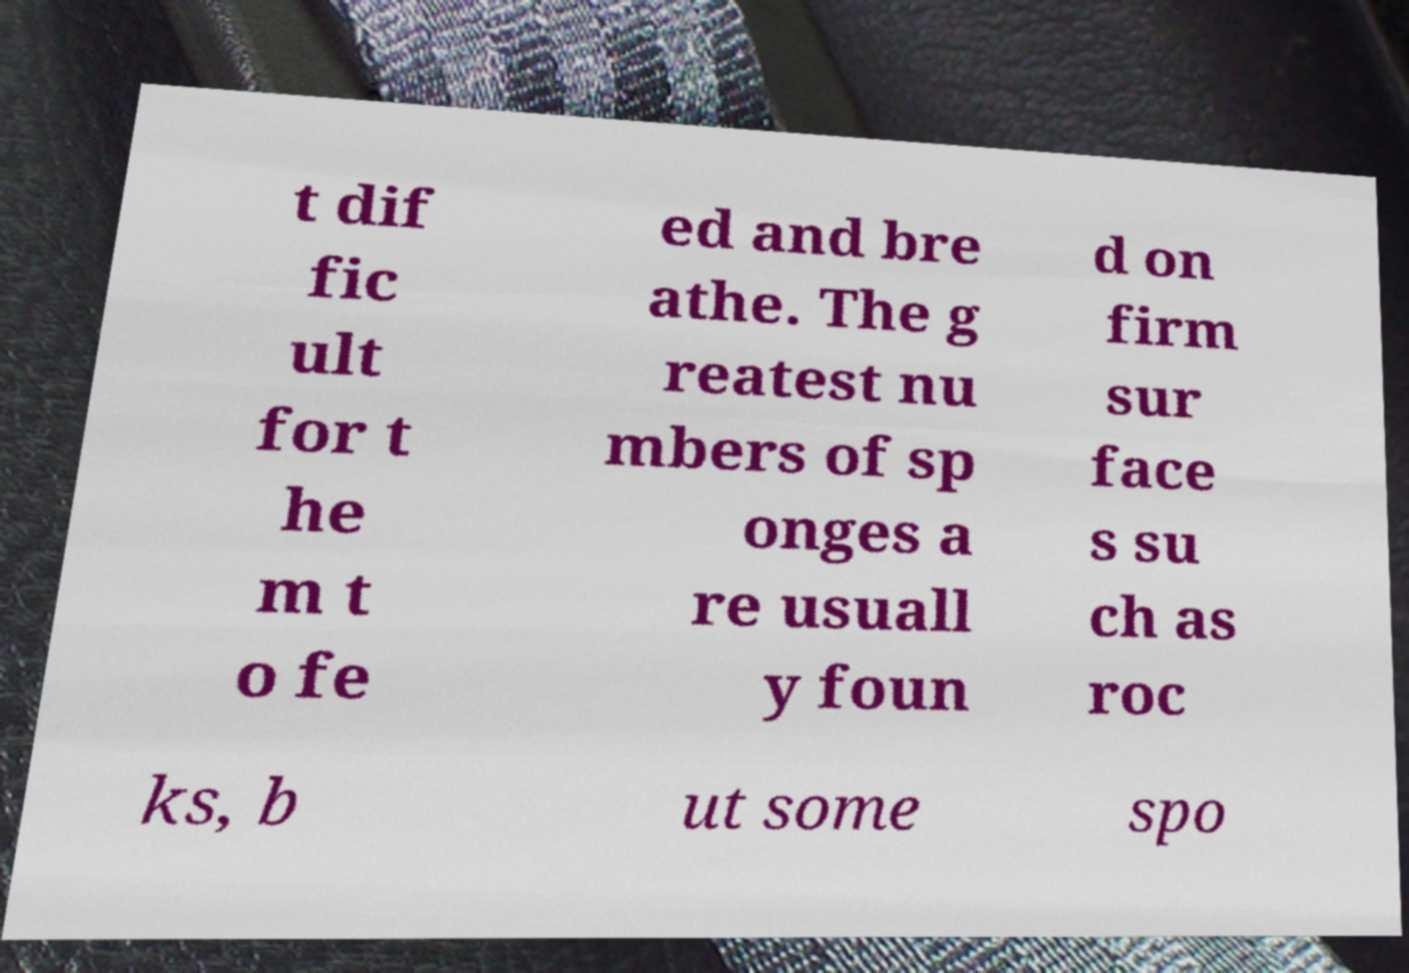Please read and relay the text visible in this image. What does it say? t dif fic ult for t he m t o fe ed and bre athe. The g reatest nu mbers of sp onges a re usuall y foun d on firm sur face s su ch as roc ks, b ut some spo 